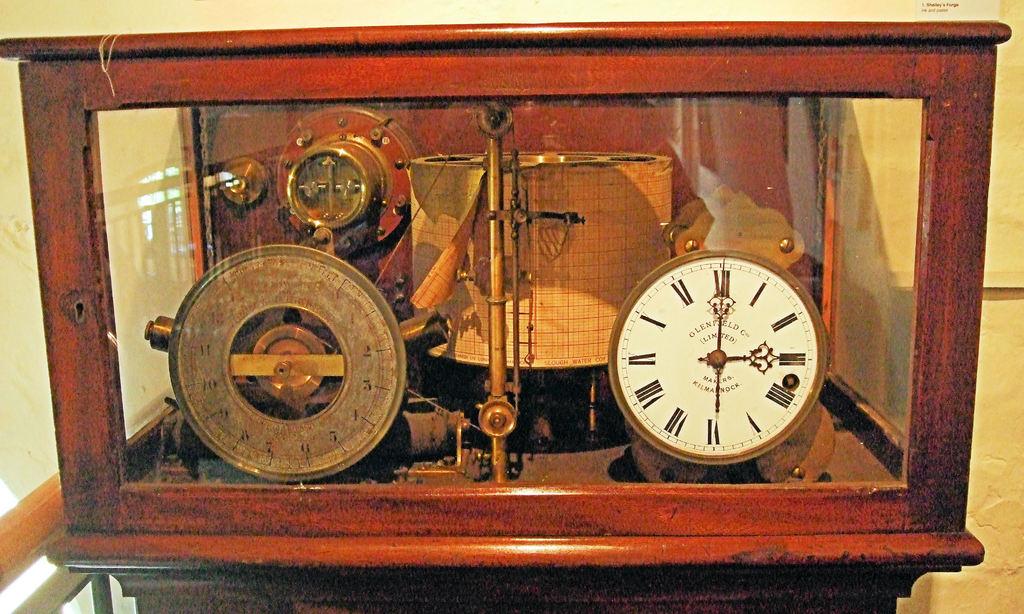What time is it?
Ensure brevity in your answer.  3:00. 